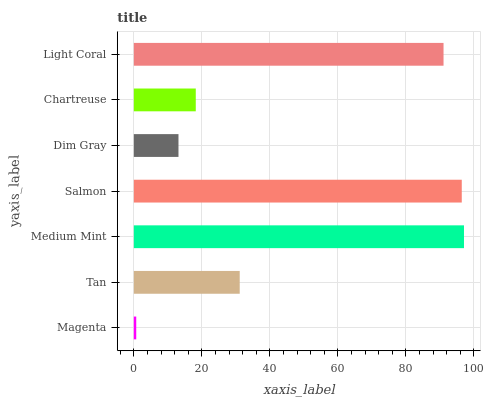Is Magenta the minimum?
Answer yes or no. Yes. Is Medium Mint the maximum?
Answer yes or no. Yes. Is Tan the minimum?
Answer yes or no. No. Is Tan the maximum?
Answer yes or no. No. Is Tan greater than Magenta?
Answer yes or no. Yes. Is Magenta less than Tan?
Answer yes or no. Yes. Is Magenta greater than Tan?
Answer yes or no. No. Is Tan less than Magenta?
Answer yes or no. No. Is Tan the high median?
Answer yes or no. Yes. Is Tan the low median?
Answer yes or no. Yes. Is Magenta the high median?
Answer yes or no. No. Is Dim Gray the low median?
Answer yes or no. No. 